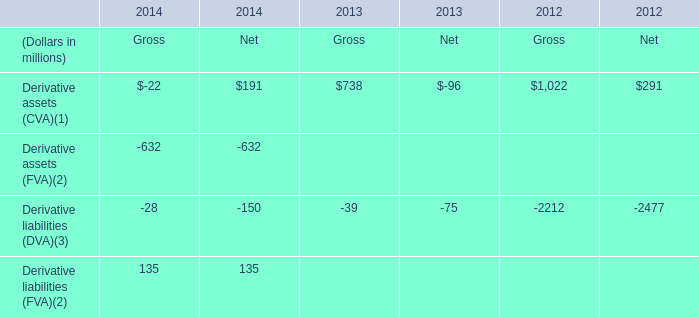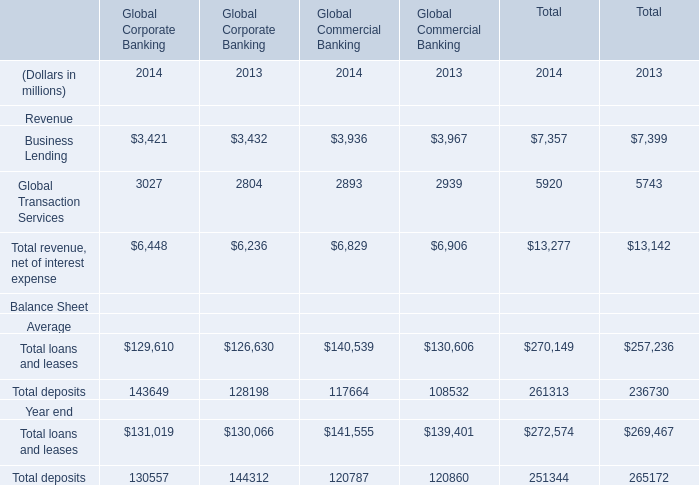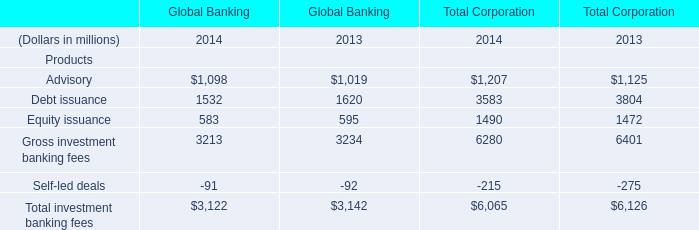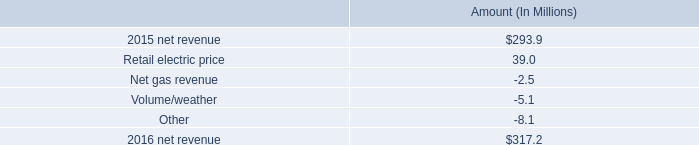Which year is Advisory for Global Banking the lowest? 
Answer: 2013. 